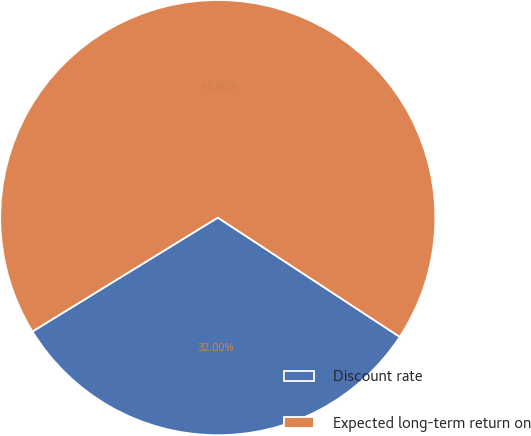Convert chart to OTSL. <chart><loc_0><loc_0><loc_500><loc_500><pie_chart><fcel>Discount rate<fcel>Expected long-term return on<nl><fcel>32.0%<fcel>68.0%<nl></chart> 